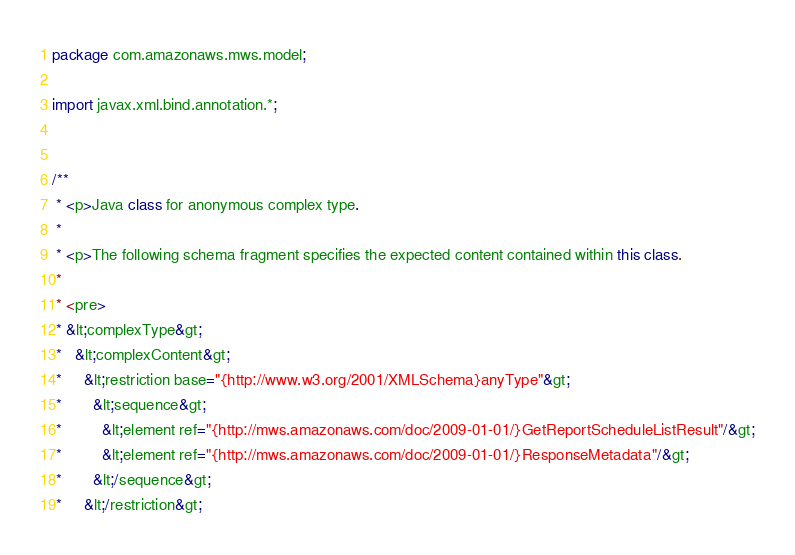Convert code to text. <code><loc_0><loc_0><loc_500><loc_500><_Java_>
package com.amazonaws.mws.model;

import javax.xml.bind.annotation.*;


/**
 * <p>Java class for anonymous complex type.
 *
 * <p>The following schema fragment specifies the expected content contained within this class.
 *
 * <pre>
 * &lt;complexType&gt;
 *   &lt;complexContent&gt;
 *     &lt;restriction base="{http://www.w3.org/2001/XMLSchema}anyType"&gt;
 *       &lt;sequence&gt;
 *         &lt;element ref="{http://mws.amazonaws.com/doc/2009-01-01/}GetReportScheduleListResult"/&gt;
 *         &lt;element ref="{http://mws.amazonaws.com/doc/2009-01-01/}ResponseMetadata"/&gt;
 *       &lt;/sequence&gt;
 *     &lt;/restriction&gt;</code> 